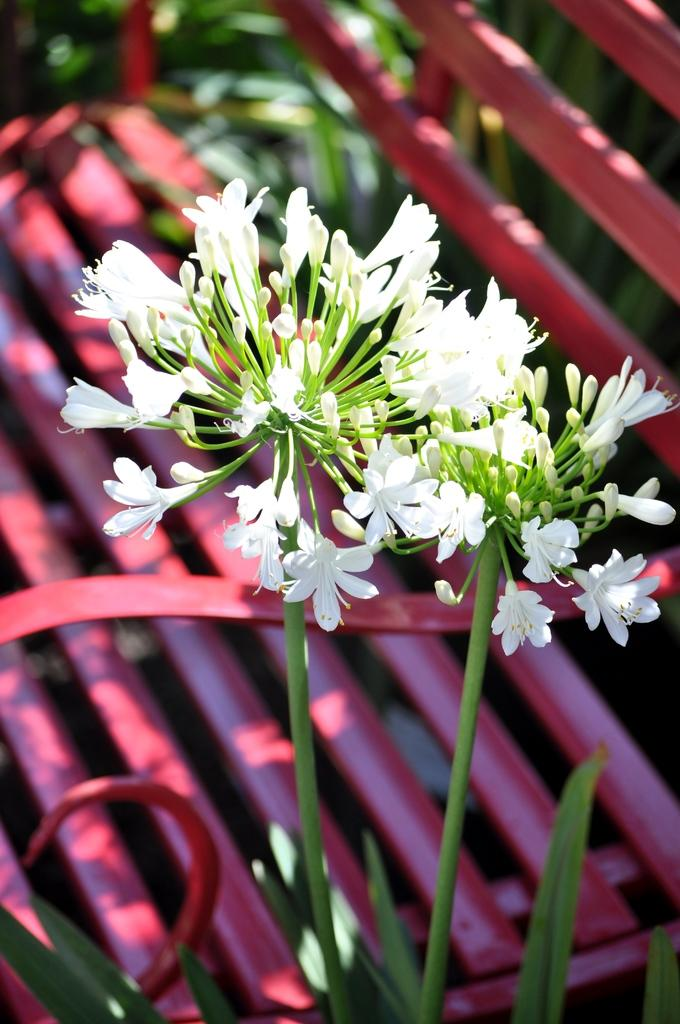What type of flowers can be seen in the image? There are tiny flowers in the image. What color are the flowers? The flowers are white in color. What else can be seen in the image besides the flowers? The flower stems and a bench are visible in the image. What color is the bench? The bench is red in color. What else is present in the image besides the flowers and bench? Leaves are present in the image. What type of dress is the person wearing in the image? There is no person or dress present in the image; it features tiny white flowers, flower stems, a red bench, and leaves. 